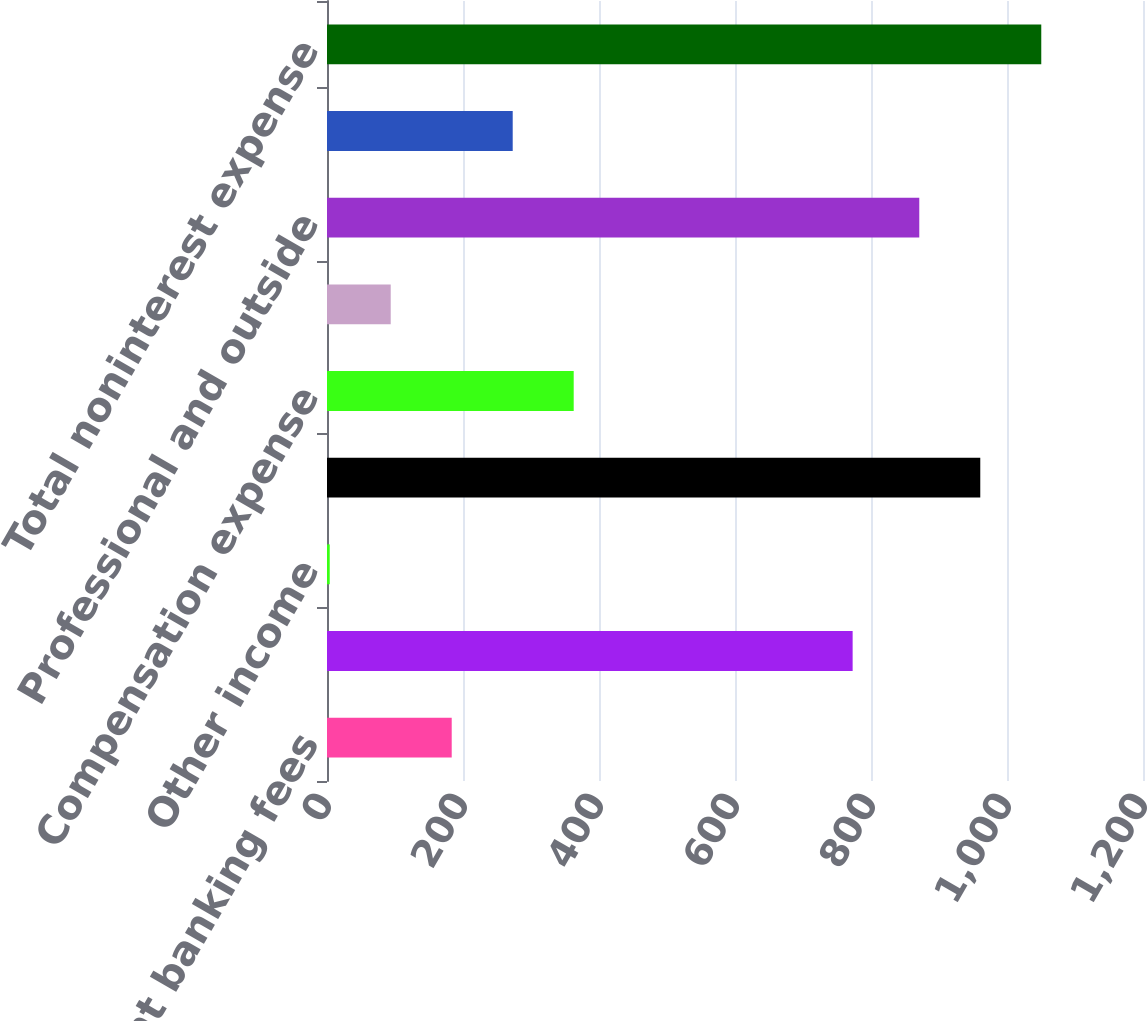Convert chart. <chart><loc_0><loc_0><loc_500><loc_500><bar_chart><fcel>Investment banking fees<fcel>Asset management<fcel>Other income<fcel>Total net revenue<fcel>Compensation expense<fcel>Technology communication and<fcel>Professional and outside<fcel>Other expense<fcel>Total noninterest expense<nl><fcel>183.4<fcel>773<fcel>4<fcel>960.7<fcel>362.8<fcel>93.7<fcel>871<fcel>273.1<fcel>1050.4<nl></chart> 